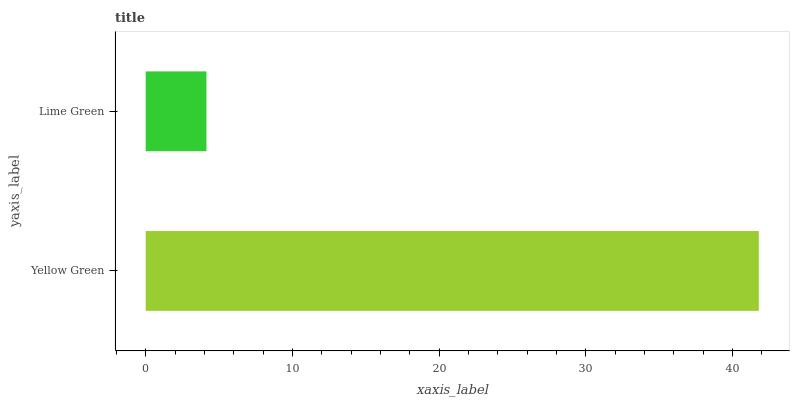Is Lime Green the minimum?
Answer yes or no. Yes. Is Yellow Green the maximum?
Answer yes or no. Yes. Is Lime Green the maximum?
Answer yes or no. No. Is Yellow Green greater than Lime Green?
Answer yes or no. Yes. Is Lime Green less than Yellow Green?
Answer yes or no. Yes. Is Lime Green greater than Yellow Green?
Answer yes or no. No. Is Yellow Green less than Lime Green?
Answer yes or no. No. Is Yellow Green the high median?
Answer yes or no. Yes. Is Lime Green the low median?
Answer yes or no. Yes. Is Lime Green the high median?
Answer yes or no. No. Is Yellow Green the low median?
Answer yes or no. No. 